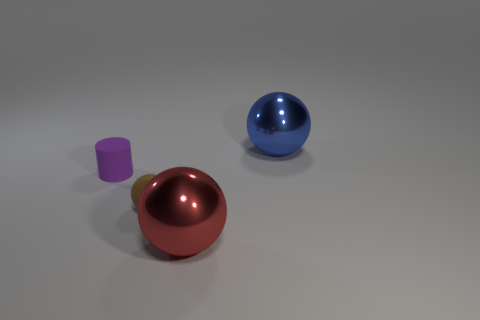There is a brown thing; is its shape the same as the shiny object on the right side of the red shiny object?
Your response must be concise. Yes. What is the color of the big shiny thing that is in front of the big metallic ball right of the large metallic thing in front of the purple cylinder?
Your answer should be very brief. Red. There is a matte ball; are there any balls in front of it?
Your answer should be very brief. Yes. Are there any big things that have the same material as the red sphere?
Keep it short and to the point. Yes. The tiny matte ball is what color?
Ensure brevity in your answer.  Brown. There is a metallic object that is behind the brown sphere; is it the same shape as the brown thing?
Provide a succinct answer. Yes. The shiny thing left of the thing to the right of the large sphere in front of the blue ball is what shape?
Keep it short and to the point. Sphere. There is a tiny object in front of the tiny purple cylinder; what is its material?
Offer a very short reply. Rubber. There is another sphere that is the same size as the red sphere; what color is it?
Your answer should be very brief. Blue. How many other things are the same shape as the small purple object?
Your answer should be very brief. 0. 